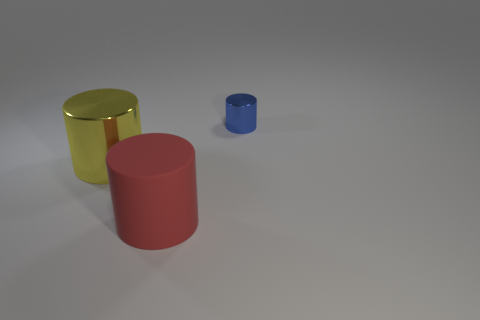Do the red rubber object and the yellow cylinder have the same size?
Your answer should be compact. Yes. There is a metallic thing left of the metal cylinder that is on the right side of the large matte cylinder; how big is it?
Give a very brief answer. Large. What number of spheres are big brown matte things or blue shiny things?
Give a very brief answer. 0. There is a blue shiny cylinder; is it the same size as the cylinder in front of the big yellow object?
Make the answer very short. No. Is the number of cylinders that are behind the large metal thing greater than the number of big yellow rubber spheres?
Ensure brevity in your answer.  Yes. There is a blue object that is the same material as the yellow thing; what is its size?
Your response must be concise. Small. What number of things are large yellow things or objects behind the red rubber object?
Make the answer very short. 2. Are there more red cylinders than shiny balls?
Give a very brief answer. Yes. Are there any other cylinders made of the same material as the large yellow cylinder?
Keep it short and to the point. Yes. The thing that is both to the right of the yellow cylinder and behind the large red thing has what shape?
Provide a short and direct response. Cylinder. 